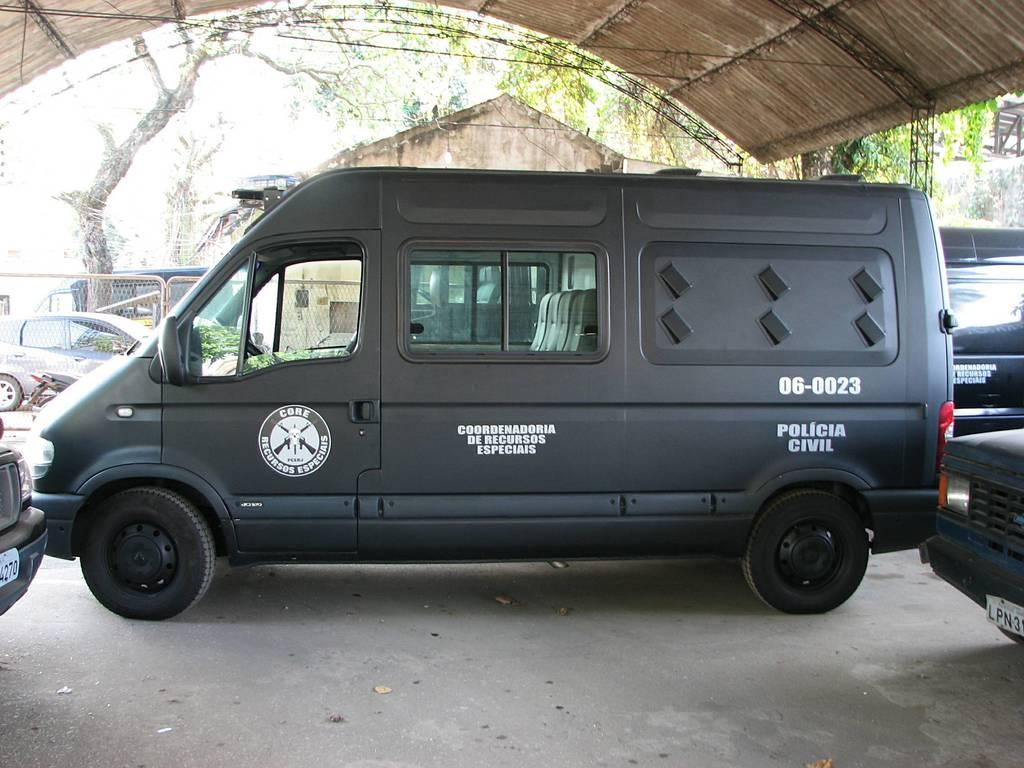<image>
Provide a brief description of the given image. The van has Core Recursos Especiais on the door. 